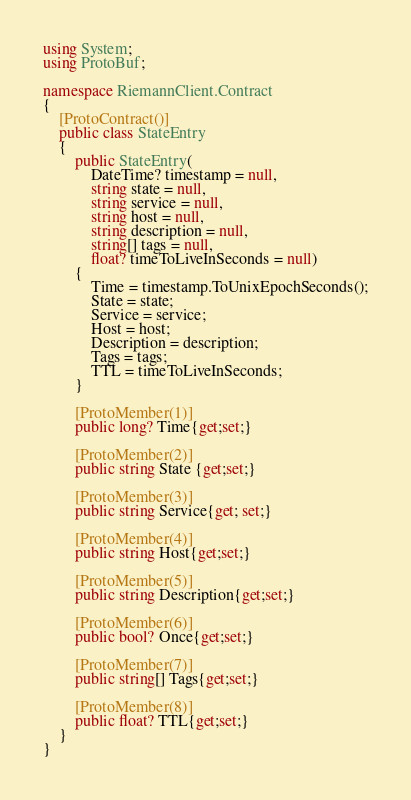<code> <loc_0><loc_0><loc_500><loc_500><_C#_>using System;
using ProtoBuf;

namespace RiemannClient.Contract
{
    [ProtoContract()]
    public class StateEntry 
    {
        public StateEntry(
            DateTime? timestamp = null, 
            string state = null, 
            string service = null, 
            string host = null, 
            string description = null, 
            string[] tags = null, 
            float? timeToLiveInSeconds = null)
        {
            Time = timestamp.ToUnixEpochSeconds();
            State = state;
            Service = service;
            Host = host;
            Description = description;
            Tags = tags;
            TTL = timeToLiveInSeconds;
        }

        [ProtoMember(1)]
        public long? Time{get;set;}
  
        [ProtoMember(2)]
        public string State {get;set;}

        [ProtoMember(3)]
        public string Service{get; set;}

        [ProtoMember(4)]
        public string Host{get;set;}
        
        [ProtoMember(5)]
        public string Description{get;set;}

        [ProtoMember(6)]
        public bool? Once{get;set;}

        [ProtoMember(7)]
        public string[] Tags{get;set;}

        [ProtoMember(8)]
        public float? TTL{get;set;}
    }
}</code> 